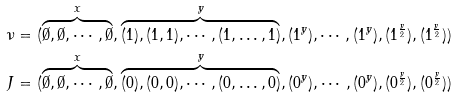<formula> <loc_0><loc_0><loc_500><loc_500>\nu & = ( \overbrace { \emptyset , \emptyset , \cdots , \emptyset } ^ { x } , \overbrace { ( 1 ) , ( 1 , 1 ) , \cdots , ( 1 , \dots , 1 ) } ^ { y } , ( 1 ^ { y } ) , \cdots , ( 1 ^ { y } ) , ( 1 ^ { \frac { y } { 2 } } ) , ( 1 ^ { \frac { y } { 2 } } ) ) \\ J & = ( \overbrace { \emptyset , \emptyset , \cdots , \emptyset } ^ { x } , \overbrace { ( 0 ) , ( 0 , 0 ) , \cdots , ( 0 , \dots , 0 ) } ^ { y } , ( 0 ^ { y } ) , \cdots , ( 0 ^ { y } ) , ( 0 ^ { \frac { y } { 2 } } ) , ( 0 ^ { \frac { y } { 2 } } ) ) \\</formula> 